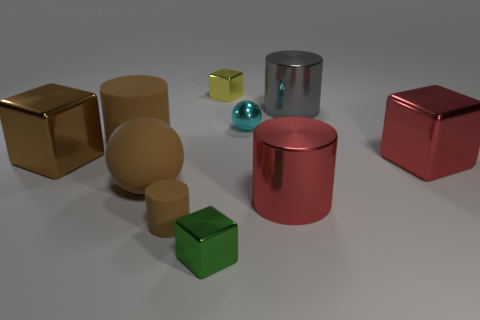Subtract 1 cubes. How many cubes are left? 3 Subtract all cylinders. How many objects are left? 6 Add 1 small red cubes. How many small red cubes exist? 1 Subtract 0 blue cylinders. How many objects are left? 10 Subtract all large red cylinders. Subtract all green things. How many objects are left? 8 Add 7 brown rubber cylinders. How many brown rubber cylinders are left? 9 